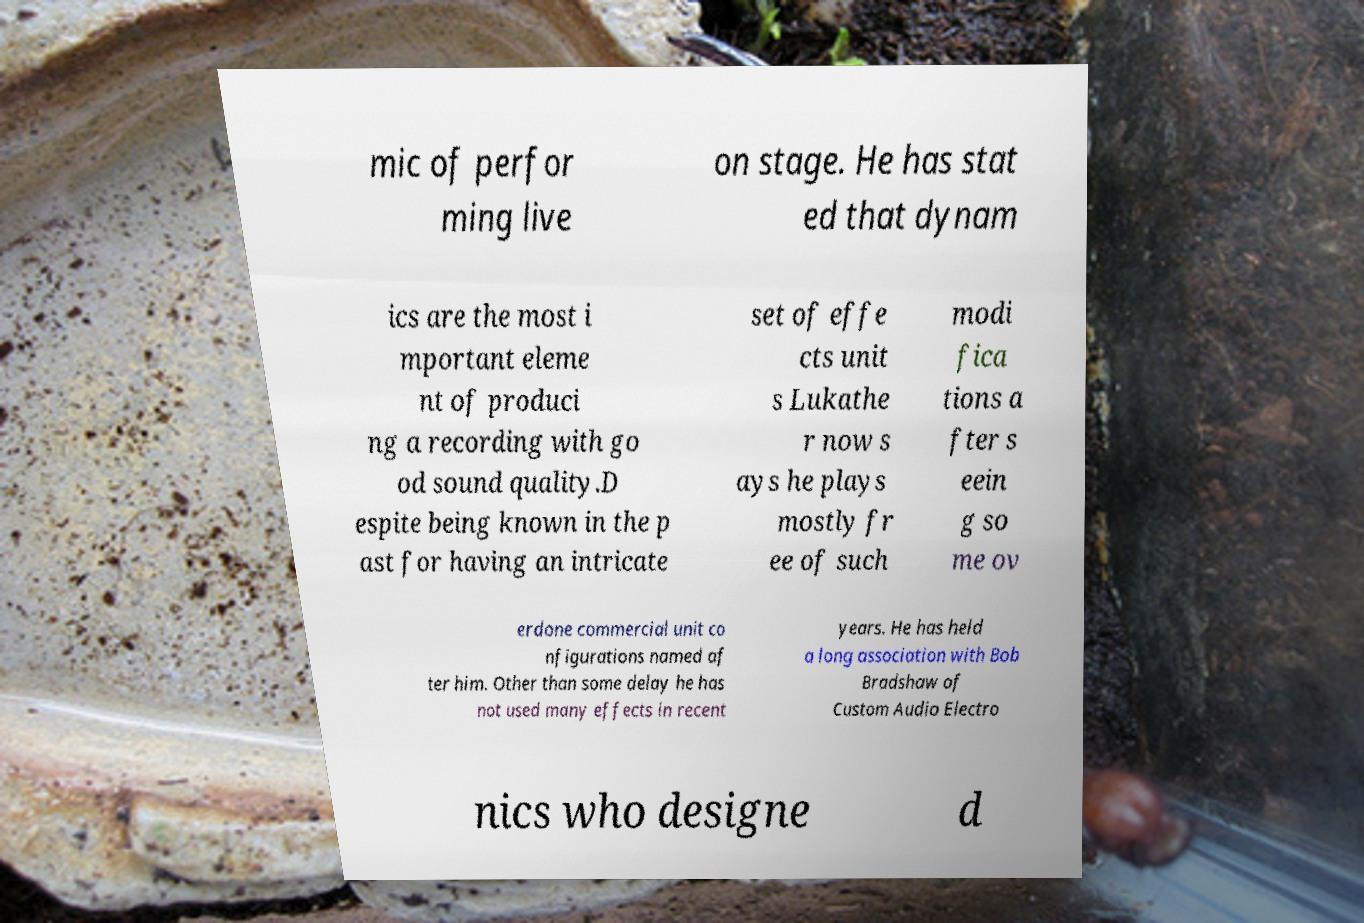For documentation purposes, I need the text within this image transcribed. Could you provide that? mic of perfor ming live on stage. He has stat ed that dynam ics are the most i mportant eleme nt of produci ng a recording with go od sound quality.D espite being known in the p ast for having an intricate set of effe cts unit s Lukathe r now s ays he plays mostly fr ee of such modi fica tions a fter s eein g so me ov erdone commercial unit co nfigurations named af ter him. Other than some delay he has not used many effects in recent years. He has held a long association with Bob Bradshaw of Custom Audio Electro nics who designe d 